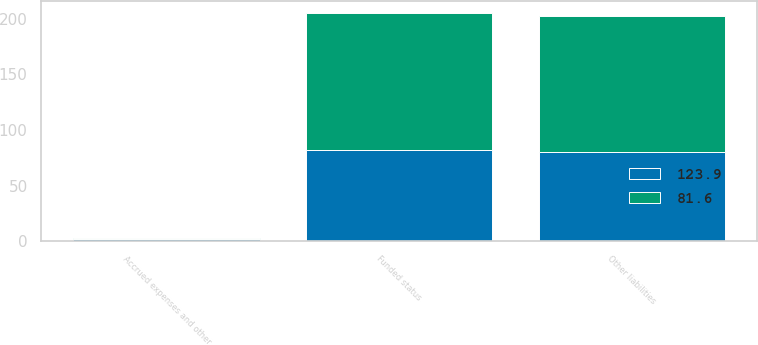<chart> <loc_0><loc_0><loc_500><loc_500><stacked_bar_chart><ecel><fcel>Funded status<fcel>Accrued expenses and other<fcel>Other liabilities<nl><fcel>123.9<fcel>81.6<fcel>1.6<fcel>80<nl><fcel>81.6<fcel>123.9<fcel>1.4<fcel>122.5<nl></chart> 